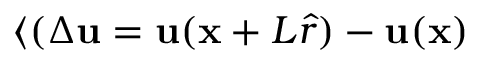<formula> <loc_0><loc_0><loc_500><loc_500>\langle ( \Delta u = u ( x + L \hat { r } ) - u ( x )</formula> 